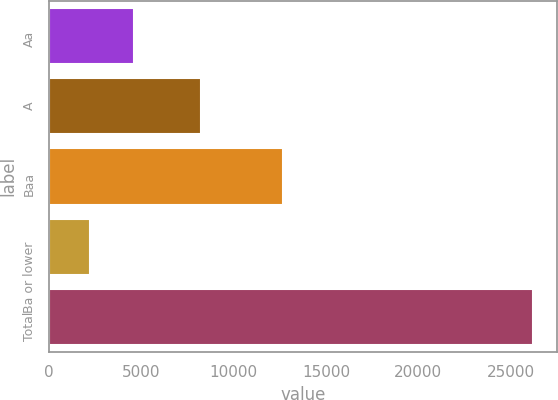<chart> <loc_0><loc_0><loc_500><loc_500><bar_chart><fcel>Aa<fcel>A<fcel>Baa<fcel>Ba or lower<fcel>Total<nl><fcel>4603.8<fcel>8196<fcel>12653<fcel>2201<fcel>26229<nl></chart> 